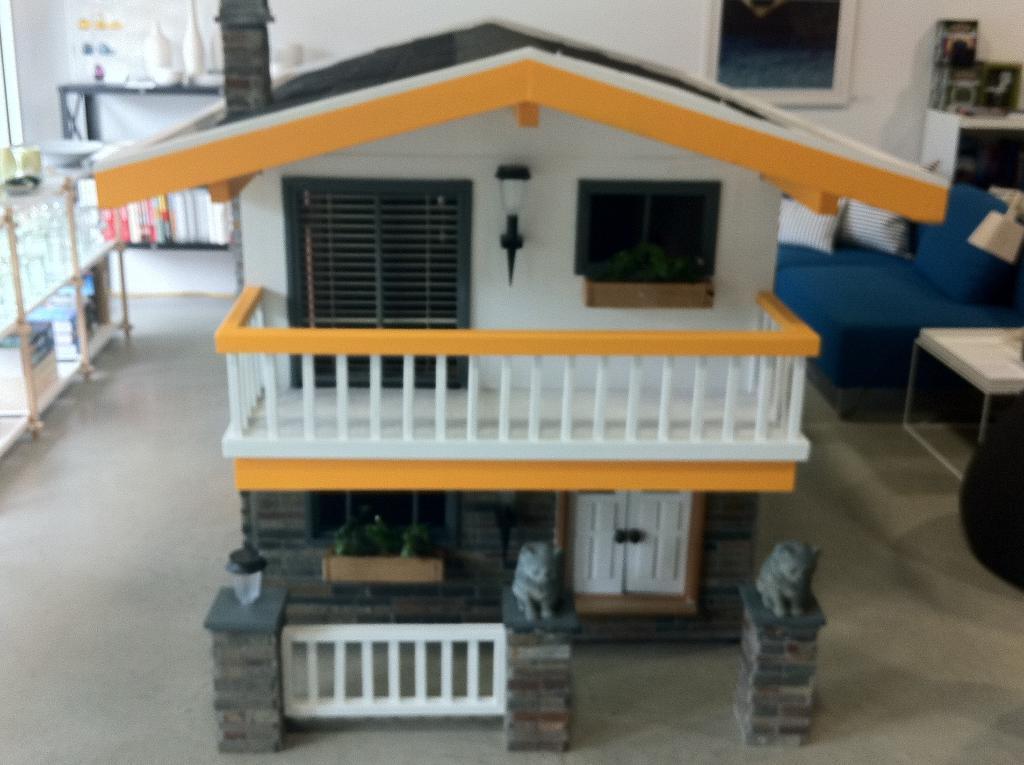In one or two sentences, can you explain what this image depicts? In this picture I can observe scale model of a house in the middle of the picture. On the right side I can observe sofa. In the background I can observe wall. 